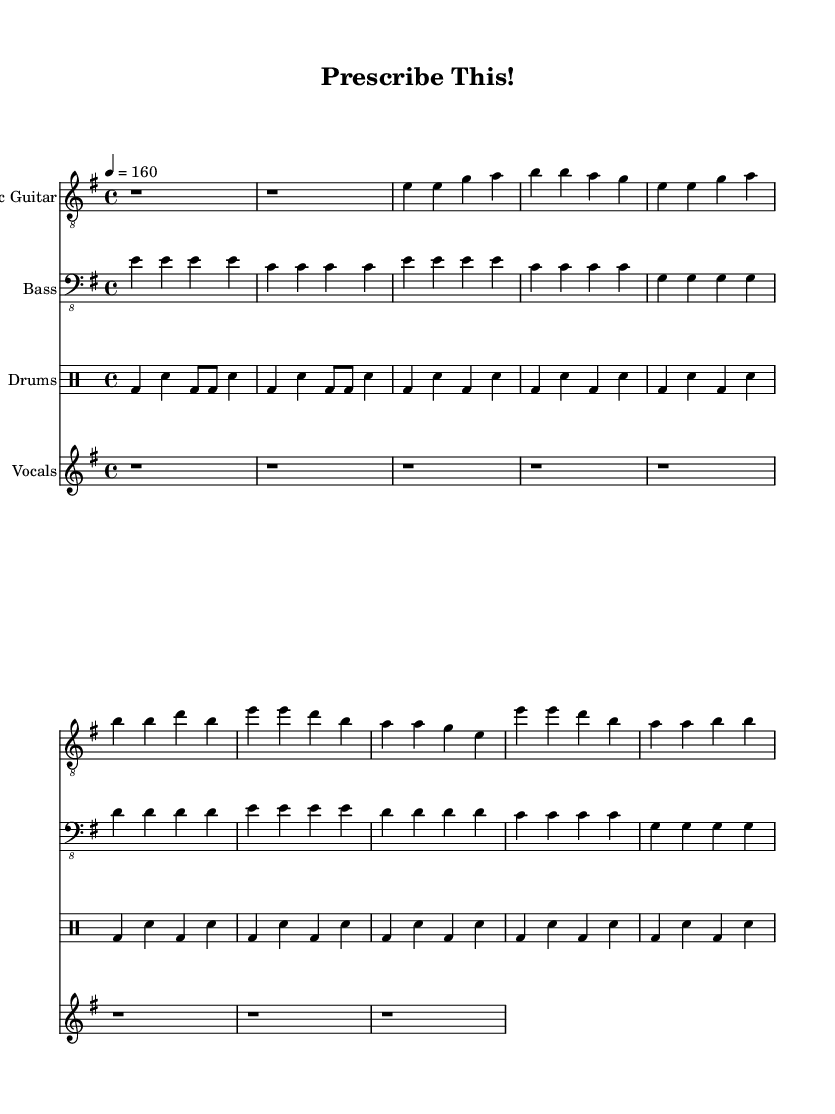What is the key signature of this music? The key signature indicated in the music is E minor, which has one sharp (F#).
Answer: E minor What is the time signature of this song? The time signature shown in the music is 4/4, meaning there are four beats in each measure.
Answer: 4/4 What is the tempo marking for this piece? The tempo is marked as 4=160, indicating the speed of the music, which translates to 160 beats per minute.
Answer: 160 How many measures are in the verse section? By counting the groupings of notes in the verse part of the sheet music, we see it contains four measures.
Answer: Four What is the main theme of the lyrics? The lyrics primarily critique prescriptive grammar and language norms, showcasing a rebellious attitude towards linguistic restrictions.
Answer: Language evolution What type of guitar clef is used for the electric guitar part? The electric guitar part uses the treble clef, which is standard for higher-pitched instruments like the guitar.
Answer: Treble In the chorus, how is the phrase "Prescribe this!" musically emphasized? The phrase "Prescribe this!" is repeated with a strong rhythm and is a focal point of the chorus, emphasizing its rebellious tone against prescriptive norms.
Answer: Strong rhythm 